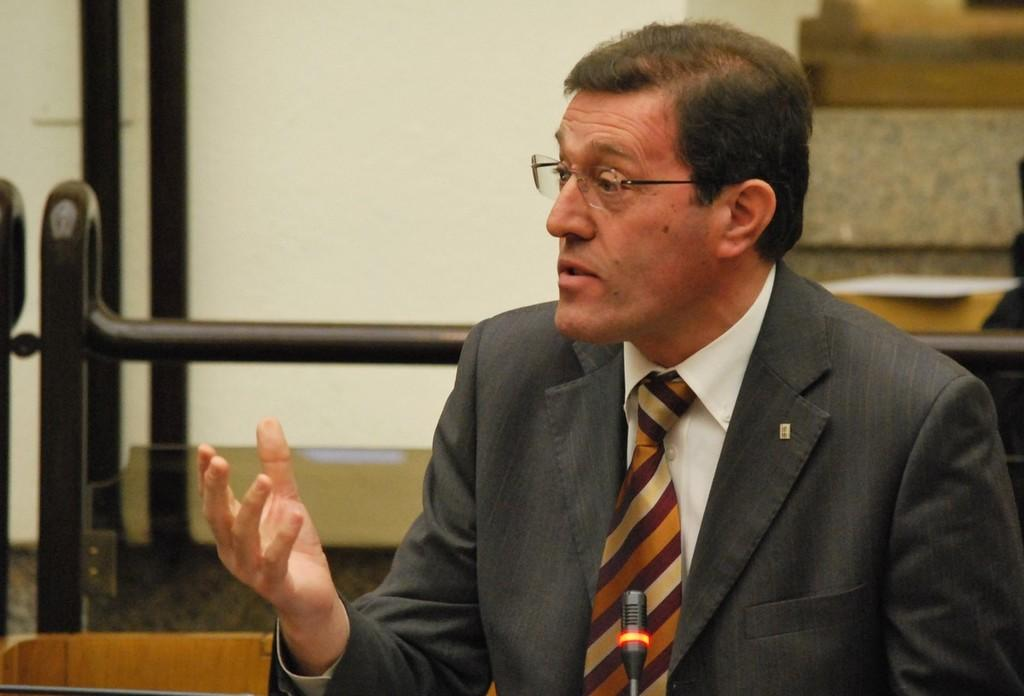Who is the main subject in the image? There is a man in the middle of the image. What can be seen in the background? There are black color objects in the background, and there is a wall. What object is located at the bottom of the image? There is a microphone at the bottom of the image. Where are the ducks sitting in the image? There are no ducks present in the image. What type of bells can be heard ringing in the background of the image? There is no sound or indication of bells in the image. 